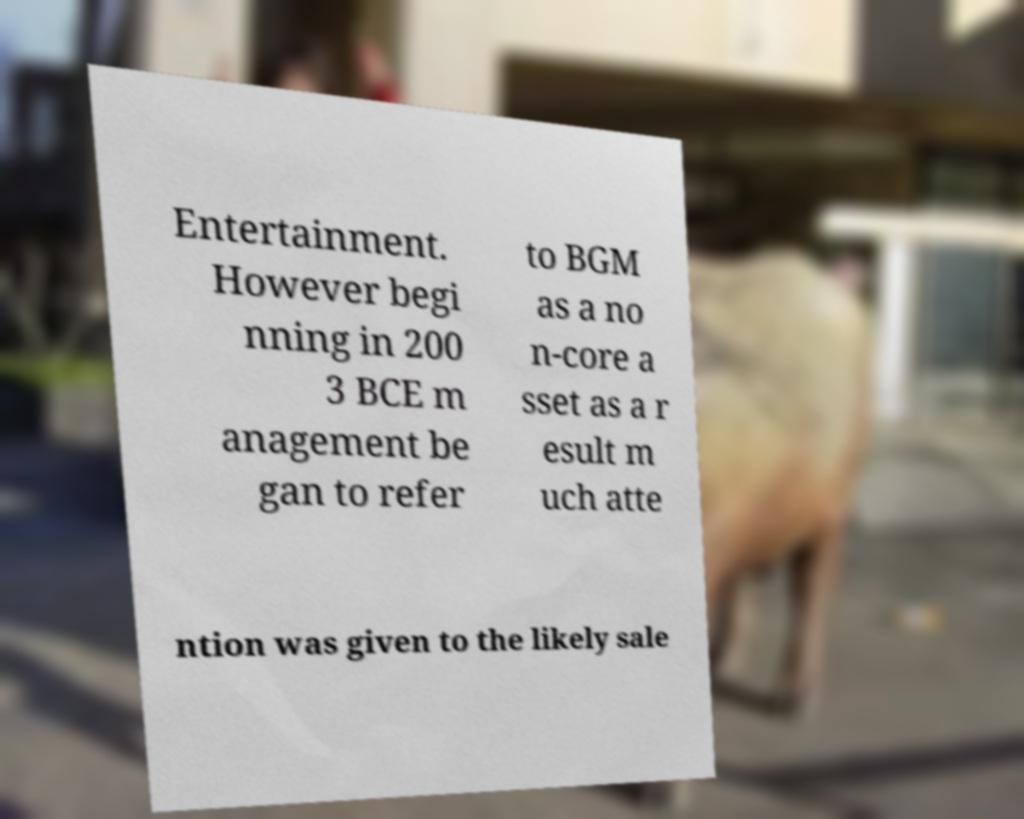Can you read and provide the text displayed in the image?This photo seems to have some interesting text. Can you extract and type it out for me? Entertainment. However begi nning in 200 3 BCE m anagement be gan to refer to BGM as a no n-core a sset as a r esult m uch atte ntion was given to the likely sale 